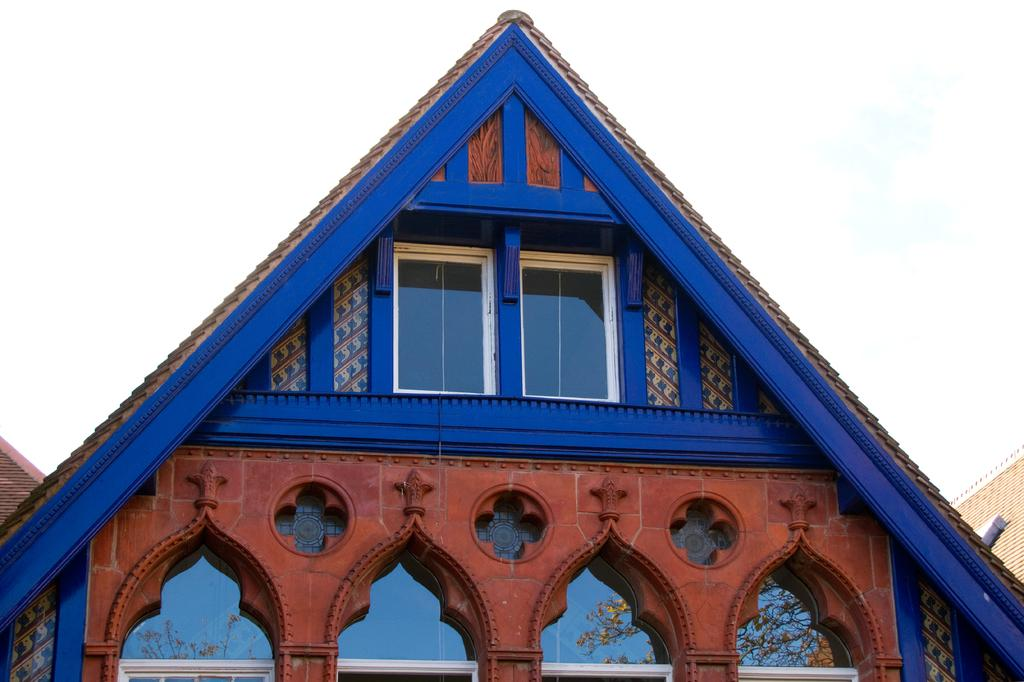What type of structures can be seen in the image? There are houses in the image. What part of the natural environment is visible in the image? The sky is visible in the background of the image. What type of brick is used to build the houses in the image? There is no information about the type of brick used to build the houses in the image. Additionally, the image does not show any bricks, as it only depicts the houses and the sky. 